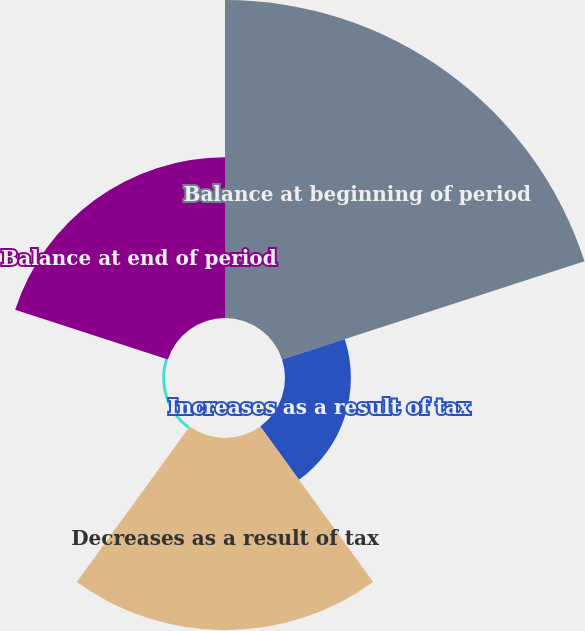Convert chart to OTSL. <chart><loc_0><loc_0><loc_500><loc_500><pie_chart><fcel>Balance at beginning of period<fcel>Increases as a result of tax<fcel>Decreases as a result of tax<fcel>Lapse of statutes of<fcel>Balance at end of period<nl><fcel>43.0%<fcel>8.91%<fcel>25.98%<fcel>0.39%<fcel>21.72%<nl></chart> 